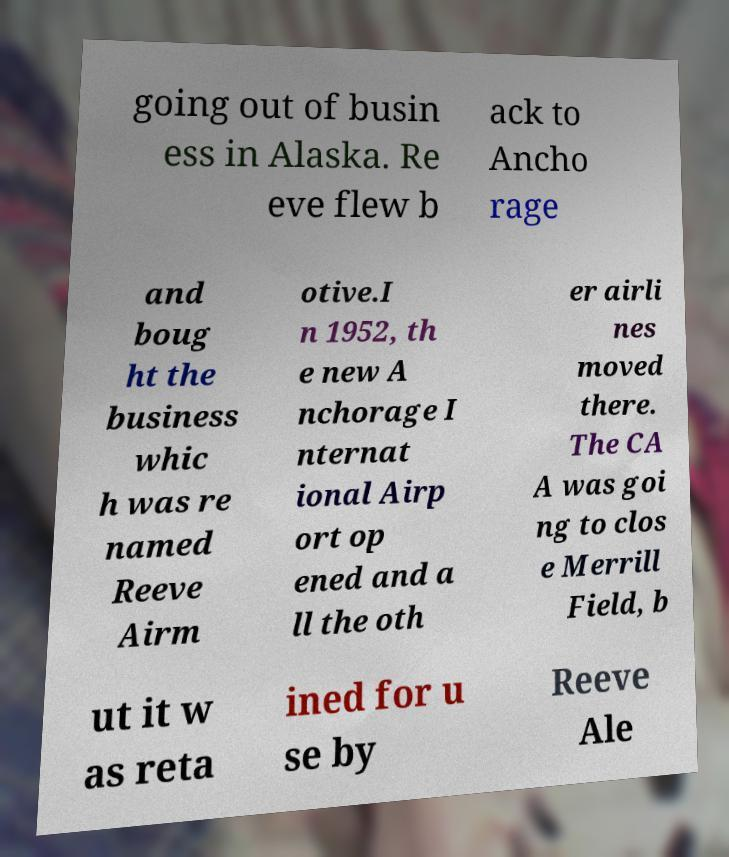I need the written content from this picture converted into text. Can you do that? going out of busin ess in Alaska. Re eve flew b ack to Ancho rage and boug ht the business whic h was re named Reeve Airm otive.I n 1952, th e new A nchorage I nternat ional Airp ort op ened and a ll the oth er airli nes moved there. The CA A was goi ng to clos e Merrill Field, b ut it w as reta ined for u se by Reeve Ale 